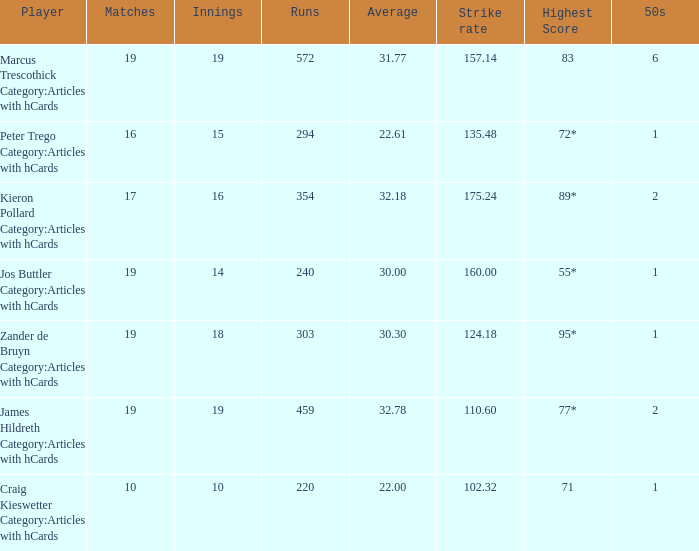How many innings for the player with a mean of 2 15.0. 